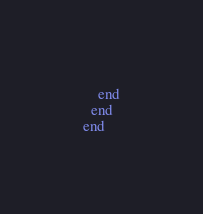<code> <loc_0><loc_0><loc_500><loc_500><_Ruby_>    end
  end
end
</code> 